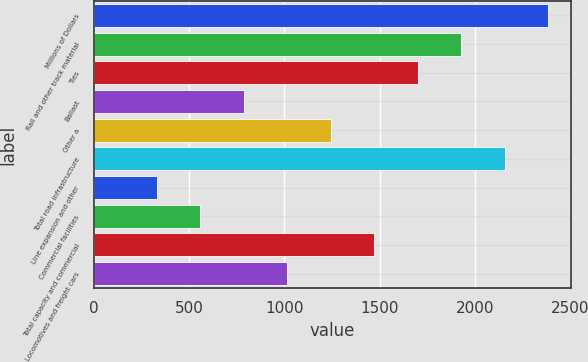Convert chart. <chart><loc_0><loc_0><loc_500><loc_500><bar_chart><fcel>Millions of Dollars<fcel>Rail and other track material<fcel>Ties<fcel>Ballast<fcel>Other a<fcel>Total road infrastructure<fcel>Line expansion and other<fcel>Commercial facilities<fcel>Total capacity and commercial<fcel>Locomotives and freight cars<nl><fcel>2384<fcel>1927.6<fcel>1699.4<fcel>786.6<fcel>1243<fcel>2155.8<fcel>330.2<fcel>558.4<fcel>1471.2<fcel>1014.8<nl></chart> 